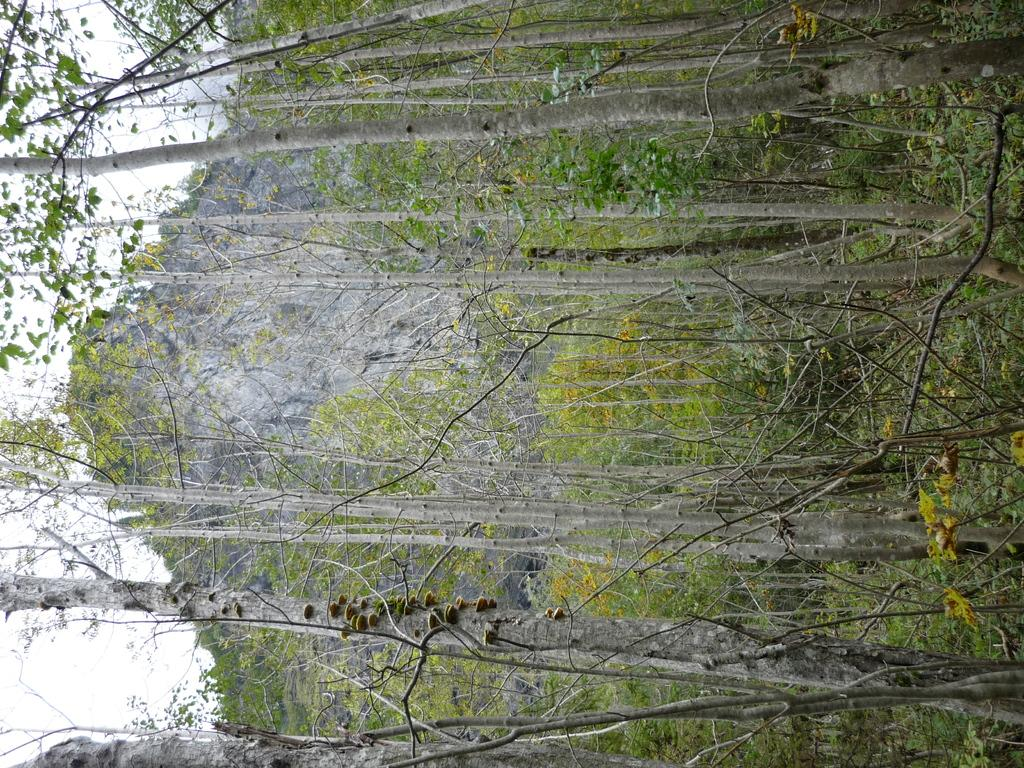What type of vegetation can be seen in the image? There are trees in the image. What geographical feature is present in the image? There is a mountain in the image. What is visible in the background of the image? The sky is visible in the background of the image. How many silk scarves can be seen hanging from the trees in the image? There is no mention of silk scarves in the image, so it is not possible to answer that question. 